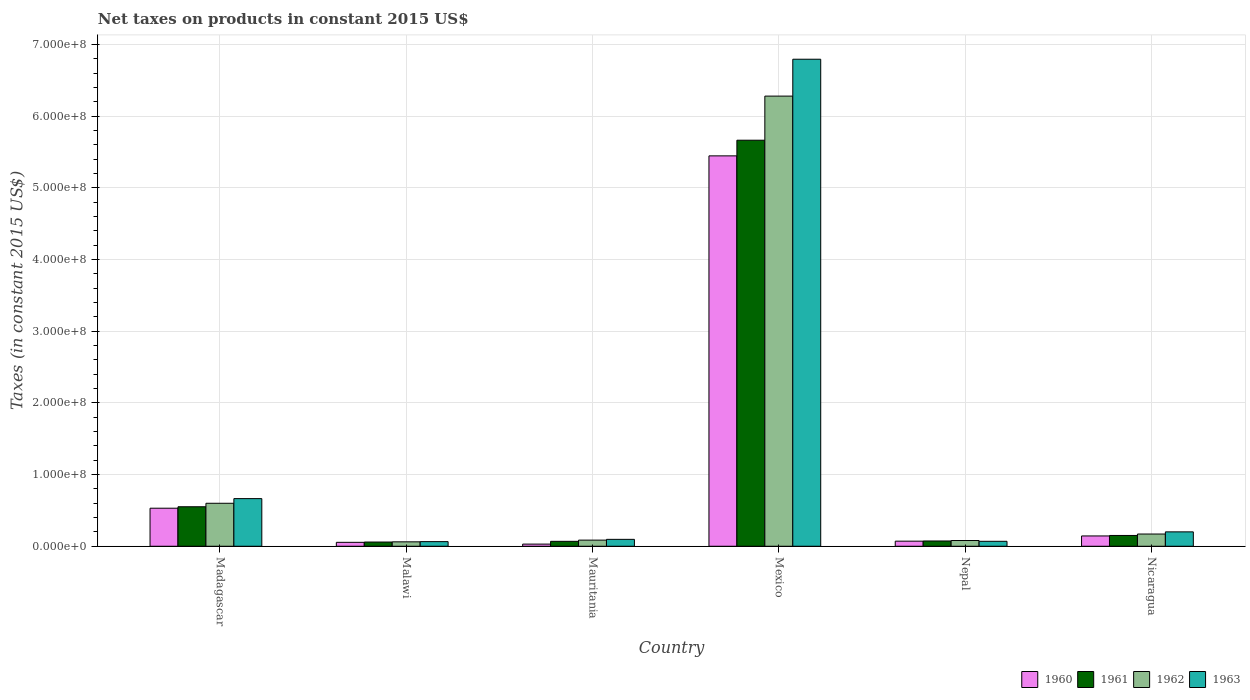How many groups of bars are there?
Your answer should be compact. 6. Are the number of bars on each tick of the X-axis equal?
Ensure brevity in your answer.  Yes. How many bars are there on the 4th tick from the left?
Provide a short and direct response. 4. In how many cases, is the number of bars for a given country not equal to the number of legend labels?
Your answer should be very brief. 0. What is the net taxes on products in 1962 in Mexico?
Offer a very short reply. 6.28e+08. Across all countries, what is the maximum net taxes on products in 1963?
Provide a succinct answer. 6.79e+08. Across all countries, what is the minimum net taxes on products in 1963?
Keep it short and to the point. 6.44e+06. In which country was the net taxes on products in 1962 maximum?
Offer a terse response. Mexico. In which country was the net taxes on products in 1960 minimum?
Keep it short and to the point. Mauritania. What is the total net taxes on products in 1961 in the graph?
Give a very brief answer. 6.57e+08. What is the difference between the net taxes on products in 1962 in Madagascar and that in Mexico?
Your answer should be very brief. -5.68e+08. What is the difference between the net taxes on products in 1962 in Nepal and the net taxes on products in 1963 in Mauritania?
Ensure brevity in your answer.  -1.62e+06. What is the average net taxes on products in 1960 per country?
Your answer should be compact. 1.05e+08. What is the difference between the net taxes on products of/in 1963 and net taxes on products of/in 1962 in Malawi?
Ensure brevity in your answer.  2.80e+05. In how many countries, is the net taxes on products in 1960 greater than 160000000 US$?
Provide a short and direct response. 1. What is the ratio of the net taxes on products in 1962 in Madagascar to that in Nicaragua?
Give a very brief answer. 3.51. Is the net taxes on products in 1962 in Nepal less than that in Nicaragua?
Ensure brevity in your answer.  Yes. What is the difference between the highest and the second highest net taxes on products in 1960?
Give a very brief answer. 3.87e+07. What is the difference between the highest and the lowest net taxes on products in 1960?
Your answer should be very brief. 5.42e+08. In how many countries, is the net taxes on products in 1961 greater than the average net taxes on products in 1961 taken over all countries?
Your answer should be compact. 1. Is the sum of the net taxes on products in 1961 in Malawi and Mexico greater than the maximum net taxes on products in 1962 across all countries?
Your answer should be very brief. No. Is it the case that in every country, the sum of the net taxes on products in 1961 and net taxes on products in 1960 is greater than the sum of net taxes on products in 1962 and net taxes on products in 1963?
Give a very brief answer. No. What does the 4th bar from the right in Mauritania represents?
Your answer should be very brief. 1960. How many bars are there?
Ensure brevity in your answer.  24. Are the values on the major ticks of Y-axis written in scientific E-notation?
Give a very brief answer. Yes. Does the graph contain any zero values?
Your response must be concise. No. Where does the legend appear in the graph?
Ensure brevity in your answer.  Bottom right. How many legend labels are there?
Keep it short and to the point. 4. What is the title of the graph?
Your response must be concise. Net taxes on products in constant 2015 US$. What is the label or title of the X-axis?
Your answer should be compact. Country. What is the label or title of the Y-axis?
Give a very brief answer. Taxes (in constant 2015 US$). What is the Taxes (in constant 2015 US$) of 1960 in Madagascar?
Your answer should be compact. 5.31e+07. What is the Taxes (in constant 2015 US$) in 1961 in Madagascar?
Your answer should be compact. 5.51e+07. What is the Taxes (in constant 2015 US$) in 1962 in Madagascar?
Your response must be concise. 6.00e+07. What is the Taxes (in constant 2015 US$) of 1963 in Madagascar?
Keep it short and to the point. 6.64e+07. What is the Taxes (in constant 2015 US$) in 1960 in Malawi?
Your answer should be very brief. 5.46e+06. What is the Taxes (in constant 2015 US$) of 1961 in Malawi?
Provide a succinct answer. 5.88e+06. What is the Taxes (in constant 2015 US$) in 1962 in Malawi?
Offer a very short reply. 6.16e+06. What is the Taxes (in constant 2015 US$) of 1963 in Malawi?
Your answer should be very brief. 6.44e+06. What is the Taxes (in constant 2015 US$) of 1960 in Mauritania?
Your answer should be very brief. 3.00e+06. What is the Taxes (in constant 2015 US$) in 1961 in Mauritania?
Offer a terse response. 6.85e+06. What is the Taxes (in constant 2015 US$) of 1962 in Mauritania?
Keep it short and to the point. 8.56e+06. What is the Taxes (in constant 2015 US$) of 1963 in Mauritania?
Keep it short and to the point. 9.63e+06. What is the Taxes (in constant 2015 US$) in 1960 in Mexico?
Provide a short and direct response. 5.45e+08. What is the Taxes (in constant 2015 US$) in 1961 in Mexico?
Provide a succinct answer. 5.66e+08. What is the Taxes (in constant 2015 US$) in 1962 in Mexico?
Give a very brief answer. 6.28e+08. What is the Taxes (in constant 2015 US$) of 1963 in Mexico?
Offer a terse response. 6.79e+08. What is the Taxes (in constant 2015 US$) in 1960 in Nepal?
Provide a short and direct response. 7.09e+06. What is the Taxes (in constant 2015 US$) in 1961 in Nepal?
Provide a short and direct response. 7.35e+06. What is the Taxes (in constant 2015 US$) of 1962 in Nepal?
Ensure brevity in your answer.  8.01e+06. What is the Taxes (in constant 2015 US$) of 1963 in Nepal?
Make the answer very short. 6.89e+06. What is the Taxes (in constant 2015 US$) of 1960 in Nicaragua?
Provide a short and direct response. 1.44e+07. What is the Taxes (in constant 2015 US$) of 1961 in Nicaragua?
Keep it short and to the point. 1.51e+07. What is the Taxes (in constant 2015 US$) in 1962 in Nicaragua?
Ensure brevity in your answer.  1.71e+07. What is the Taxes (in constant 2015 US$) of 1963 in Nicaragua?
Give a very brief answer. 2.01e+07. Across all countries, what is the maximum Taxes (in constant 2015 US$) in 1960?
Provide a succinct answer. 5.45e+08. Across all countries, what is the maximum Taxes (in constant 2015 US$) of 1961?
Your response must be concise. 5.66e+08. Across all countries, what is the maximum Taxes (in constant 2015 US$) of 1962?
Provide a short and direct response. 6.28e+08. Across all countries, what is the maximum Taxes (in constant 2015 US$) in 1963?
Your answer should be very brief. 6.79e+08. Across all countries, what is the minimum Taxes (in constant 2015 US$) of 1960?
Offer a terse response. 3.00e+06. Across all countries, what is the minimum Taxes (in constant 2015 US$) of 1961?
Offer a very short reply. 5.88e+06. Across all countries, what is the minimum Taxes (in constant 2015 US$) of 1962?
Your answer should be very brief. 6.16e+06. Across all countries, what is the minimum Taxes (in constant 2015 US$) in 1963?
Your answer should be very brief. 6.44e+06. What is the total Taxes (in constant 2015 US$) in 1960 in the graph?
Your response must be concise. 6.28e+08. What is the total Taxes (in constant 2015 US$) in 1961 in the graph?
Ensure brevity in your answer.  6.57e+08. What is the total Taxes (in constant 2015 US$) in 1962 in the graph?
Make the answer very short. 7.28e+08. What is the total Taxes (in constant 2015 US$) in 1963 in the graph?
Ensure brevity in your answer.  7.89e+08. What is the difference between the Taxes (in constant 2015 US$) of 1960 in Madagascar and that in Malawi?
Offer a terse response. 4.76e+07. What is the difference between the Taxes (in constant 2015 US$) in 1961 in Madagascar and that in Malawi?
Your answer should be very brief. 4.92e+07. What is the difference between the Taxes (in constant 2015 US$) of 1962 in Madagascar and that in Malawi?
Your answer should be compact. 5.38e+07. What is the difference between the Taxes (in constant 2015 US$) of 1963 in Madagascar and that in Malawi?
Provide a succinct answer. 6.00e+07. What is the difference between the Taxes (in constant 2015 US$) of 1960 in Madagascar and that in Mauritania?
Ensure brevity in your answer.  5.01e+07. What is the difference between the Taxes (in constant 2015 US$) of 1961 in Madagascar and that in Mauritania?
Your answer should be very brief. 4.82e+07. What is the difference between the Taxes (in constant 2015 US$) in 1962 in Madagascar and that in Mauritania?
Keep it short and to the point. 5.14e+07. What is the difference between the Taxes (in constant 2015 US$) in 1963 in Madagascar and that in Mauritania?
Keep it short and to the point. 5.68e+07. What is the difference between the Taxes (in constant 2015 US$) in 1960 in Madagascar and that in Mexico?
Keep it short and to the point. -4.91e+08. What is the difference between the Taxes (in constant 2015 US$) in 1961 in Madagascar and that in Mexico?
Provide a succinct answer. -5.11e+08. What is the difference between the Taxes (in constant 2015 US$) of 1962 in Madagascar and that in Mexico?
Offer a very short reply. -5.68e+08. What is the difference between the Taxes (in constant 2015 US$) of 1963 in Madagascar and that in Mexico?
Offer a terse response. -6.13e+08. What is the difference between the Taxes (in constant 2015 US$) of 1960 in Madagascar and that in Nepal?
Your answer should be compact. 4.60e+07. What is the difference between the Taxes (in constant 2015 US$) in 1961 in Madagascar and that in Nepal?
Make the answer very short. 4.77e+07. What is the difference between the Taxes (in constant 2015 US$) in 1962 in Madagascar and that in Nepal?
Your answer should be compact. 5.19e+07. What is the difference between the Taxes (in constant 2015 US$) of 1963 in Madagascar and that in Nepal?
Your answer should be very brief. 5.95e+07. What is the difference between the Taxes (in constant 2015 US$) in 1960 in Madagascar and that in Nicaragua?
Provide a succinct answer. 3.87e+07. What is the difference between the Taxes (in constant 2015 US$) in 1961 in Madagascar and that in Nicaragua?
Make the answer very short. 4.00e+07. What is the difference between the Taxes (in constant 2015 US$) in 1962 in Madagascar and that in Nicaragua?
Your answer should be very brief. 4.29e+07. What is the difference between the Taxes (in constant 2015 US$) in 1963 in Madagascar and that in Nicaragua?
Your answer should be compact. 4.64e+07. What is the difference between the Taxes (in constant 2015 US$) in 1960 in Malawi and that in Mauritania?
Give a very brief answer. 2.46e+06. What is the difference between the Taxes (in constant 2015 US$) in 1961 in Malawi and that in Mauritania?
Provide a succinct answer. -9.67e+05. What is the difference between the Taxes (in constant 2015 US$) of 1962 in Malawi and that in Mauritania?
Offer a terse response. -2.40e+06. What is the difference between the Taxes (in constant 2015 US$) of 1963 in Malawi and that in Mauritania?
Your answer should be compact. -3.19e+06. What is the difference between the Taxes (in constant 2015 US$) of 1960 in Malawi and that in Mexico?
Offer a terse response. -5.39e+08. What is the difference between the Taxes (in constant 2015 US$) of 1961 in Malawi and that in Mexico?
Provide a short and direct response. -5.61e+08. What is the difference between the Taxes (in constant 2015 US$) in 1962 in Malawi and that in Mexico?
Ensure brevity in your answer.  -6.22e+08. What is the difference between the Taxes (in constant 2015 US$) in 1963 in Malawi and that in Mexico?
Offer a very short reply. -6.73e+08. What is the difference between the Taxes (in constant 2015 US$) of 1960 in Malawi and that in Nepal?
Make the answer very short. -1.63e+06. What is the difference between the Taxes (in constant 2015 US$) of 1961 in Malawi and that in Nepal?
Make the answer very short. -1.47e+06. What is the difference between the Taxes (in constant 2015 US$) of 1962 in Malawi and that in Nepal?
Make the answer very short. -1.85e+06. What is the difference between the Taxes (in constant 2015 US$) in 1963 in Malawi and that in Nepal?
Keep it short and to the point. -4.50e+05. What is the difference between the Taxes (in constant 2015 US$) of 1960 in Malawi and that in Nicaragua?
Provide a succinct answer. -8.93e+06. What is the difference between the Taxes (in constant 2015 US$) in 1961 in Malawi and that in Nicaragua?
Offer a terse response. -9.18e+06. What is the difference between the Taxes (in constant 2015 US$) in 1962 in Malawi and that in Nicaragua?
Provide a succinct answer. -1.09e+07. What is the difference between the Taxes (in constant 2015 US$) of 1963 in Malawi and that in Nicaragua?
Make the answer very short. -1.36e+07. What is the difference between the Taxes (in constant 2015 US$) in 1960 in Mauritania and that in Mexico?
Give a very brief answer. -5.42e+08. What is the difference between the Taxes (in constant 2015 US$) of 1961 in Mauritania and that in Mexico?
Your answer should be very brief. -5.60e+08. What is the difference between the Taxes (in constant 2015 US$) in 1962 in Mauritania and that in Mexico?
Give a very brief answer. -6.19e+08. What is the difference between the Taxes (in constant 2015 US$) in 1963 in Mauritania and that in Mexico?
Offer a very short reply. -6.70e+08. What is the difference between the Taxes (in constant 2015 US$) of 1960 in Mauritania and that in Nepal?
Ensure brevity in your answer.  -4.09e+06. What is the difference between the Taxes (in constant 2015 US$) in 1961 in Mauritania and that in Nepal?
Your response must be concise. -5.03e+05. What is the difference between the Taxes (in constant 2015 US$) in 1962 in Mauritania and that in Nepal?
Offer a very short reply. 5.53e+05. What is the difference between the Taxes (in constant 2015 US$) of 1963 in Mauritania and that in Nepal?
Provide a succinct answer. 2.74e+06. What is the difference between the Taxes (in constant 2015 US$) in 1960 in Mauritania and that in Nicaragua?
Your answer should be compact. -1.14e+07. What is the difference between the Taxes (in constant 2015 US$) in 1961 in Mauritania and that in Nicaragua?
Make the answer very short. -8.21e+06. What is the difference between the Taxes (in constant 2015 US$) of 1962 in Mauritania and that in Nicaragua?
Provide a short and direct response. -8.50e+06. What is the difference between the Taxes (in constant 2015 US$) of 1963 in Mauritania and that in Nicaragua?
Ensure brevity in your answer.  -1.04e+07. What is the difference between the Taxes (in constant 2015 US$) in 1960 in Mexico and that in Nepal?
Your response must be concise. 5.37e+08. What is the difference between the Taxes (in constant 2015 US$) in 1961 in Mexico and that in Nepal?
Offer a very short reply. 5.59e+08. What is the difference between the Taxes (in constant 2015 US$) in 1962 in Mexico and that in Nepal?
Provide a succinct answer. 6.20e+08. What is the difference between the Taxes (in constant 2015 US$) in 1963 in Mexico and that in Nepal?
Make the answer very short. 6.72e+08. What is the difference between the Taxes (in constant 2015 US$) in 1960 in Mexico and that in Nicaragua?
Give a very brief answer. 5.30e+08. What is the difference between the Taxes (in constant 2015 US$) in 1961 in Mexico and that in Nicaragua?
Offer a very short reply. 5.51e+08. What is the difference between the Taxes (in constant 2015 US$) in 1962 in Mexico and that in Nicaragua?
Give a very brief answer. 6.11e+08. What is the difference between the Taxes (in constant 2015 US$) of 1963 in Mexico and that in Nicaragua?
Your answer should be very brief. 6.59e+08. What is the difference between the Taxes (in constant 2015 US$) of 1960 in Nepal and that in Nicaragua?
Your response must be concise. -7.30e+06. What is the difference between the Taxes (in constant 2015 US$) of 1961 in Nepal and that in Nicaragua?
Offer a very short reply. -7.71e+06. What is the difference between the Taxes (in constant 2015 US$) in 1962 in Nepal and that in Nicaragua?
Offer a very short reply. -9.06e+06. What is the difference between the Taxes (in constant 2015 US$) in 1963 in Nepal and that in Nicaragua?
Provide a short and direct response. -1.32e+07. What is the difference between the Taxes (in constant 2015 US$) in 1960 in Madagascar and the Taxes (in constant 2015 US$) in 1961 in Malawi?
Offer a terse response. 4.72e+07. What is the difference between the Taxes (in constant 2015 US$) of 1960 in Madagascar and the Taxes (in constant 2015 US$) of 1962 in Malawi?
Your answer should be compact. 4.69e+07. What is the difference between the Taxes (in constant 2015 US$) in 1960 in Madagascar and the Taxes (in constant 2015 US$) in 1963 in Malawi?
Provide a short and direct response. 4.66e+07. What is the difference between the Taxes (in constant 2015 US$) in 1961 in Madagascar and the Taxes (in constant 2015 US$) in 1962 in Malawi?
Give a very brief answer. 4.89e+07. What is the difference between the Taxes (in constant 2015 US$) of 1961 in Madagascar and the Taxes (in constant 2015 US$) of 1963 in Malawi?
Your response must be concise. 4.87e+07. What is the difference between the Taxes (in constant 2015 US$) of 1962 in Madagascar and the Taxes (in constant 2015 US$) of 1963 in Malawi?
Your response must be concise. 5.35e+07. What is the difference between the Taxes (in constant 2015 US$) of 1960 in Madagascar and the Taxes (in constant 2015 US$) of 1961 in Mauritania?
Your response must be concise. 4.62e+07. What is the difference between the Taxes (in constant 2015 US$) of 1960 in Madagascar and the Taxes (in constant 2015 US$) of 1962 in Mauritania?
Provide a short and direct response. 4.45e+07. What is the difference between the Taxes (in constant 2015 US$) of 1960 in Madagascar and the Taxes (in constant 2015 US$) of 1963 in Mauritania?
Your answer should be very brief. 4.34e+07. What is the difference between the Taxes (in constant 2015 US$) in 1961 in Madagascar and the Taxes (in constant 2015 US$) in 1962 in Mauritania?
Your answer should be very brief. 4.65e+07. What is the difference between the Taxes (in constant 2015 US$) of 1961 in Madagascar and the Taxes (in constant 2015 US$) of 1963 in Mauritania?
Provide a succinct answer. 4.55e+07. What is the difference between the Taxes (in constant 2015 US$) of 1962 in Madagascar and the Taxes (in constant 2015 US$) of 1963 in Mauritania?
Offer a very short reply. 5.03e+07. What is the difference between the Taxes (in constant 2015 US$) of 1960 in Madagascar and the Taxes (in constant 2015 US$) of 1961 in Mexico?
Your answer should be compact. -5.13e+08. What is the difference between the Taxes (in constant 2015 US$) in 1960 in Madagascar and the Taxes (in constant 2015 US$) in 1962 in Mexico?
Your answer should be compact. -5.75e+08. What is the difference between the Taxes (in constant 2015 US$) of 1960 in Madagascar and the Taxes (in constant 2015 US$) of 1963 in Mexico?
Give a very brief answer. -6.26e+08. What is the difference between the Taxes (in constant 2015 US$) of 1961 in Madagascar and the Taxes (in constant 2015 US$) of 1962 in Mexico?
Your answer should be compact. -5.73e+08. What is the difference between the Taxes (in constant 2015 US$) in 1961 in Madagascar and the Taxes (in constant 2015 US$) in 1963 in Mexico?
Offer a terse response. -6.24e+08. What is the difference between the Taxes (in constant 2015 US$) in 1962 in Madagascar and the Taxes (in constant 2015 US$) in 1963 in Mexico?
Your answer should be very brief. -6.19e+08. What is the difference between the Taxes (in constant 2015 US$) in 1960 in Madagascar and the Taxes (in constant 2015 US$) in 1961 in Nepal?
Your answer should be very brief. 4.57e+07. What is the difference between the Taxes (in constant 2015 US$) in 1960 in Madagascar and the Taxes (in constant 2015 US$) in 1962 in Nepal?
Give a very brief answer. 4.51e+07. What is the difference between the Taxes (in constant 2015 US$) of 1960 in Madagascar and the Taxes (in constant 2015 US$) of 1963 in Nepal?
Your answer should be compact. 4.62e+07. What is the difference between the Taxes (in constant 2015 US$) of 1961 in Madagascar and the Taxes (in constant 2015 US$) of 1962 in Nepal?
Ensure brevity in your answer.  4.71e+07. What is the difference between the Taxes (in constant 2015 US$) of 1961 in Madagascar and the Taxes (in constant 2015 US$) of 1963 in Nepal?
Your response must be concise. 4.82e+07. What is the difference between the Taxes (in constant 2015 US$) in 1962 in Madagascar and the Taxes (in constant 2015 US$) in 1963 in Nepal?
Ensure brevity in your answer.  5.31e+07. What is the difference between the Taxes (in constant 2015 US$) in 1960 in Madagascar and the Taxes (in constant 2015 US$) in 1961 in Nicaragua?
Offer a terse response. 3.80e+07. What is the difference between the Taxes (in constant 2015 US$) in 1960 in Madagascar and the Taxes (in constant 2015 US$) in 1962 in Nicaragua?
Your response must be concise. 3.60e+07. What is the difference between the Taxes (in constant 2015 US$) in 1960 in Madagascar and the Taxes (in constant 2015 US$) in 1963 in Nicaragua?
Make the answer very short. 3.30e+07. What is the difference between the Taxes (in constant 2015 US$) in 1961 in Madagascar and the Taxes (in constant 2015 US$) in 1962 in Nicaragua?
Your response must be concise. 3.80e+07. What is the difference between the Taxes (in constant 2015 US$) in 1961 in Madagascar and the Taxes (in constant 2015 US$) in 1963 in Nicaragua?
Offer a very short reply. 3.50e+07. What is the difference between the Taxes (in constant 2015 US$) of 1962 in Madagascar and the Taxes (in constant 2015 US$) of 1963 in Nicaragua?
Ensure brevity in your answer.  3.99e+07. What is the difference between the Taxes (in constant 2015 US$) in 1960 in Malawi and the Taxes (in constant 2015 US$) in 1961 in Mauritania?
Keep it short and to the point. -1.39e+06. What is the difference between the Taxes (in constant 2015 US$) in 1960 in Malawi and the Taxes (in constant 2015 US$) in 1962 in Mauritania?
Your response must be concise. -3.10e+06. What is the difference between the Taxes (in constant 2015 US$) of 1960 in Malawi and the Taxes (in constant 2015 US$) of 1963 in Mauritania?
Offer a very short reply. -4.17e+06. What is the difference between the Taxes (in constant 2015 US$) of 1961 in Malawi and the Taxes (in constant 2015 US$) of 1962 in Mauritania?
Offer a very short reply. -2.68e+06. What is the difference between the Taxes (in constant 2015 US$) of 1961 in Malawi and the Taxes (in constant 2015 US$) of 1963 in Mauritania?
Offer a terse response. -3.75e+06. What is the difference between the Taxes (in constant 2015 US$) of 1962 in Malawi and the Taxes (in constant 2015 US$) of 1963 in Mauritania?
Give a very brief answer. -3.47e+06. What is the difference between the Taxes (in constant 2015 US$) of 1960 in Malawi and the Taxes (in constant 2015 US$) of 1961 in Mexico?
Give a very brief answer. -5.61e+08. What is the difference between the Taxes (in constant 2015 US$) of 1960 in Malawi and the Taxes (in constant 2015 US$) of 1962 in Mexico?
Your answer should be very brief. -6.22e+08. What is the difference between the Taxes (in constant 2015 US$) of 1960 in Malawi and the Taxes (in constant 2015 US$) of 1963 in Mexico?
Your answer should be compact. -6.74e+08. What is the difference between the Taxes (in constant 2015 US$) of 1961 in Malawi and the Taxes (in constant 2015 US$) of 1962 in Mexico?
Make the answer very short. -6.22e+08. What is the difference between the Taxes (in constant 2015 US$) of 1961 in Malawi and the Taxes (in constant 2015 US$) of 1963 in Mexico?
Your response must be concise. -6.73e+08. What is the difference between the Taxes (in constant 2015 US$) of 1962 in Malawi and the Taxes (in constant 2015 US$) of 1963 in Mexico?
Provide a short and direct response. -6.73e+08. What is the difference between the Taxes (in constant 2015 US$) in 1960 in Malawi and the Taxes (in constant 2015 US$) in 1961 in Nepal?
Give a very brief answer. -1.89e+06. What is the difference between the Taxes (in constant 2015 US$) of 1960 in Malawi and the Taxes (in constant 2015 US$) of 1962 in Nepal?
Offer a terse response. -2.55e+06. What is the difference between the Taxes (in constant 2015 US$) of 1960 in Malawi and the Taxes (in constant 2015 US$) of 1963 in Nepal?
Provide a short and direct response. -1.43e+06. What is the difference between the Taxes (in constant 2015 US$) of 1961 in Malawi and the Taxes (in constant 2015 US$) of 1962 in Nepal?
Provide a short and direct response. -2.13e+06. What is the difference between the Taxes (in constant 2015 US$) in 1961 in Malawi and the Taxes (in constant 2015 US$) in 1963 in Nepal?
Provide a succinct answer. -1.01e+06. What is the difference between the Taxes (in constant 2015 US$) of 1962 in Malawi and the Taxes (in constant 2015 US$) of 1963 in Nepal?
Make the answer very short. -7.30e+05. What is the difference between the Taxes (in constant 2015 US$) of 1960 in Malawi and the Taxes (in constant 2015 US$) of 1961 in Nicaragua?
Your answer should be very brief. -9.60e+06. What is the difference between the Taxes (in constant 2015 US$) of 1960 in Malawi and the Taxes (in constant 2015 US$) of 1962 in Nicaragua?
Keep it short and to the point. -1.16e+07. What is the difference between the Taxes (in constant 2015 US$) in 1960 in Malawi and the Taxes (in constant 2015 US$) in 1963 in Nicaragua?
Your answer should be compact. -1.46e+07. What is the difference between the Taxes (in constant 2015 US$) in 1961 in Malawi and the Taxes (in constant 2015 US$) in 1962 in Nicaragua?
Give a very brief answer. -1.12e+07. What is the difference between the Taxes (in constant 2015 US$) of 1961 in Malawi and the Taxes (in constant 2015 US$) of 1963 in Nicaragua?
Provide a succinct answer. -1.42e+07. What is the difference between the Taxes (in constant 2015 US$) in 1962 in Malawi and the Taxes (in constant 2015 US$) in 1963 in Nicaragua?
Keep it short and to the point. -1.39e+07. What is the difference between the Taxes (in constant 2015 US$) in 1960 in Mauritania and the Taxes (in constant 2015 US$) in 1961 in Mexico?
Your answer should be very brief. -5.63e+08. What is the difference between the Taxes (in constant 2015 US$) of 1960 in Mauritania and the Taxes (in constant 2015 US$) of 1962 in Mexico?
Offer a very short reply. -6.25e+08. What is the difference between the Taxes (in constant 2015 US$) in 1960 in Mauritania and the Taxes (in constant 2015 US$) in 1963 in Mexico?
Your answer should be very brief. -6.76e+08. What is the difference between the Taxes (in constant 2015 US$) in 1961 in Mauritania and the Taxes (in constant 2015 US$) in 1962 in Mexico?
Provide a succinct answer. -6.21e+08. What is the difference between the Taxes (in constant 2015 US$) of 1961 in Mauritania and the Taxes (in constant 2015 US$) of 1963 in Mexico?
Your answer should be compact. -6.73e+08. What is the difference between the Taxes (in constant 2015 US$) of 1962 in Mauritania and the Taxes (in constant 2015 US$) of 1963 in Mexico?
Give a very brief answer. -6.71e+08. What is the difference between the Taxes (in constant 2015 US$) in 1960 in Mauritania and the Taxes (in constant 2015 US$) in 1961 in Nepal?
Ensure brevity in your answer.  -4.35e+06. What is the difference between the Taxes (in constant 2015 US$) in 1960 in Mauritania and the Taxes (in constant 2015 US$) in 1962 in Nepal?
Provide a short and direct response. -5.01e+06. What is the difference between the Taxes (in constant 2015 US$) of 1960 in Mauritania and the Taxes (in constant 2015 US$) of 1963 in Nepal?
Your response must be concise. -3.89e+06. What is the difference between the Taxes (in constant 2015 US$) in 1961 in Mauritania and the Taxes (in constant 2015 US$) in 1962 in Nepal?
Provide a succinct answer. -1.16e+06. What is the difference between the Taxes (in constant 2015 US$) in 1961 in Mauritania and the Taxes (in constant 2015 US$) in 1963 in Nepal?
Offer a terse response. -4.29e+04. What is the difference between the Taxes (in constant 2015 US$) of 1962 in Mauritania and the Taxes (in constant 2015 US$) of 1963 in Nepal?
Give a very brief answer. 1.67e+06. What is the difference between the Taxes (in constant 2015 US$) of 1960 in Mauritania and the Taxes (in constant 2015 US$) of 1961 in Nicaragua?
Offer a terse response. -1.21e+07. What is the difference between the Taxes (in constant 2015 US$) of 1960 in Mauritania and the Taxes (in constant 2015 US$) of 1962 in Nicaragua?
Ensure brevity in your answer.  -1.41e+07. What is the difference between the Taxes (in constant 2015 US$) in 1960 in Mauritania and the Taxes (in constant 2015 US$) in 1963 in Nicaragua?
Make the answer very short. -1.71e+07. What is the difference between the Taxes (in constant 2015 US$) of 1961 in Mauritania and the Taxes (in constant 2015 US$) of 1962 in Nicaragua?
Offer a terse response. -1.02e+07. What is the difference between the Taxes (in constant 2015 US$) in 1961 in Mauritania and the Taxes (in constant 2015 US$) in 1963 in Nicaragua?
Offer a terse response. -1.32e+07. What is the difference between the Taxes (in constant 2015 US$) of 1962 in Mauritania and the Taxes (in constant 2015 US$) of 1963 in Nicaragua?
Keep it short and to the point. -1.15e+07. What is the difference between the Taxes (in constant 2015 US$) in 1960 in Mexico and the Taxes (in constant 2015 US$) in 1961 in Nepal?
Your answer should be compact. 5.37e+08. What is the difference between the Taxes (in constant 2015 US$) of 1960 in Mexico and the Taxes (in constant 2015 US$) of 1962 in Nepal?
Provide a succinct answer. 5.37e+08. What is the difference between the Taxes (in constant 2015 US$) in 1960 in Mexico and the Taxes (in constant 2015 US$) in 1963 in Nepal?
Provide a succinct answer. 5.38e+08. What is the difference between the Taxes (in constant 2015 US$) in 1961 in Mexico and the Taxes (in constant 2015 US$) in 1962 in Nepal?
Offer a very short reply. 5.58e+08. What is the difference between the Taxes (in constant 2015 US$) in 1961 in Mexico and the Taxes (in constant 2015 US$) in 1963 in Nepal?
Offer a terse response. 5.60e+08. What is the difference between the Taxes (in constant 2015 US$) in 1962 in Mexico and the Taxes (in constant 2015 US$) in 1963 in Nepal?
Keep it short and to the point. 6.21e+08. What is the difference between the Taxes (in constant 2015 US$) of 1960 in Mexico and the Taxes (in constant 2015 US$) of 1961 in Nicaragua?
Give a very brief answer. 5.30e+08. What is the difference between the Taxes (in constant 2015 US$) in 1960 in Mexico and the Taxes (in constant 2015 US$) in 1962 in Nicaragua?
Your answer should be very brief. 5.28e+08. What is the difference between the Taxes (in constant 2015 US$) of 1960 in Mexico and the Taxes (in constant 2015 US$) of 1963 in Nicaragua?
Provide a succinct answer. 5.24e+08. What is the difference between the Taxes (in constant 2015 US$) of 1961 in Mexico and the Taxes (in constant 2015 US$) of 1962 in Nicaragua?
Your answer should be compact. 5.49e+08. What is the difference between the Taxes (in constant 2015 US$) in 1961 in Mexico and the Taxes (in constant 2015 US$) in 1963 in Nicaragua?
Provide a succinct answer. 5.46e+08. What is the difference between the Taxes (in constant 2015 US$) in 1962 in Mexico and the Taxes (in constant 2015 US$) in 1963 in Nicaragua?
Make the answer very short. 6.08e+08. What is the difference between the Taxes (in constant 2015 US$) of 1960 in Nepal and the Taxes (in constant 2015 US$) of 1961 in Nicaragua?
Your answer should be compact. -7.97e+06. What is the difference between the Taxes (in constant 2015 US$) of 1960 in Nepal and the Taxes (in constant 2015 US$) of 1962 in Nicaragua?
Your response must be concise. -9.98e+06. What is the difference between the Taxes (in constant 2015 US$) of 1960 in Nepal and the Taxes (in constant 2015 US$) of 1963 in Nicaragua?
Your answer should be compact. -1.30e+07. What is the difference between the Taxes (in constant 2015 US$) in 1961 in Nepal and the Taxes (in constant 2015 US$) in 1962 in Nicaragua?
Provide a short and direct response. -9.71e+06. What is the difference between the Taxes (in constant 2015 US$) in 1961 in Nepal and the Taxes (in constant 2015 US$) in 1963 in Nicaragua?
Ensure brevity in your answer.  -1.27e+07. What is the difference between the Taxes (in constant 2015 US$) of 1962 in Nepal and the Taxes (in constant 2015 US$) of 1963 in Nicaragua?
Provide a succinct answer. -1.21e+07. What is the average Taxes (in constant 2015 US$) in 1960 per country?
Offer a terse response. 1.05e+08. What is the average Taxes (in constant 2015 US$) in 1961 per country?
Offer a very short reply. 1.09e+08. What is the average Taxes (in constant 2015 US$) in 1962 per country?
Give a very brief answer. 1.21e+08. What is the average Taxes (in constant 2015 US$) in 1963 per country?
Your response must be concise. 1.31e+08. What is the difference between the Taxes (in constant 2015 US$) of 1960 and Taxes (in constant 2015 US$) of 1961 in Madagascar?
Ensure brevity in your answer.  -2.03e+06. What is the difference between the Taxes (in constant 2015 US$) in 1960 and Taxes (in constant 2015 US$) in 1962 in Madagascar?
Provide a short and direct response. -6.89e+06. What is the difference between the Taxes (in constant 2015 US$) of 1960 and Taxes (in constant 2015 US$) of 1963 in Madagascar?
Offer a very short reply. -1.34e+07. What is the difference between the Taxes (in constant 2015 US$) of 1961 and Taxes (in constant 2015 US$) of 1962 in Madagascar?
Your answer should be very brief. -4.86e+06. What is the difference between the Taxes (in constant 2015 US$) of 1961 and Taxes (in constant 2015 US$) of 1963 in Madagascar?
Your response must be concise. -1.13e+07. What is the difference between the Taxes (in constant 2015 US$) of 1962 and Taxes (in constant 2015 US$) of 1963 in Madagascar?
Offer a very short reply. -6.48e+06. What is the difference between the Taxes (in constant 2015 US$) in 1960 and Taxes (in constant 2015 US$) in 1961 in Malawi?
Your answer should be compact. -4.20e+05. What is the difference between the Taxes (in constant 2015 US$) of 1960 and Taxes (in constant 2015 US$) of 1962 in Malawi?
Your response must be concise. -7.00e+05. What is the difference between the Taxes (in constant 2015 US$) of 1960 and Taxes (in constant 2015 US$) of 1963 in Malawi?
Your answer should be very brief. -9.80e+05. What is the difference between the Taxes (in constant 2015 US$) of 1961 and Taxes (in constant 2015 US$) of 1962 in Malawi?
Provide a succinct answer. -2.80e+05. What is the difference between the Taxes (in constant 2015 US$) of 1961 and Taxes (in constant 2015 US$) of 1963 in Malawi?
Provide a succinct answer. -5.60e+05. What is the difference between the Taxes (in constant 2015 US$) of 1962 and Taxes (in constant 2015 US$) of 1963 in Malawi?
Offer a terse response. -2.80e+05. What is the difference between the Taxes (in constant 2015 US$) of 1960 and Taxes (in constant 2015 US$) of 1961 in Mauritania?
Your answer should be very brief. -3.85e+06. What is the difference between the Taxes (in constant 2015 US$) of 1960 and Taxes (in constant 2015 US$) of 1962 in Mauritania?
Provide a short and direct response. -5.56e+06. What is the difference between the Taxes (in constant 2015 US$) of 1960 and Taxes (in constant 2015 US$) of 1963 in Mauritania?
Your response must be concise. -6.63e+06. What is the difference between the Taxes (in constant 2015 US$) in 1961 and Taxes (in constant 2015 US$) in 1962 in Mauritania?
Give a very brief answer. -1.71e+06. What is the difference between the Taxes (in constant 2015 US$) of 1961 and Taxes (in constant 2015 US$) of 1963 in Mauritania?
Your answer should be compact. -2.78e+06. What is the difference between the Taxes (in constant 2015 US$) in 1962 and Taxes (in constant 2015 US$) in 1963 in Mauritania?
Ensure brevity in your answer.  -1.07e+06. What is the difference between the Taxes (in constant 2015 US$) of 1960 and Taxes (in constant 2015 US$) of 1961 in Mexico?
Provide a short and direct response. -2.18e+07. What is the difference between the Taxes (in constant 2015 US$) of 1960 and Taxes (in constant 2015 US$) of 1962 in Mexico?
Provide a short and direct response. -8.34e+07. What is the difference between the Taxes (in constant 2015 US$) in 1960 and Taxes (in constant 2015 US$) in 1963 in Mexico?
Ensure brevity in your answer.  -1.35e+08. What is the difference between the Taxes (in constant 2015 US$) in 1961 and Taxes (in constant 2015 US$) in 1962 in Mexico?
Offer a very short reply. -6.15e+07. What is the difference between the Taxes (in constant 2015 US$) in 1961 and Taxes (in constant 2015 US$) in 1963 in Mexico?
Your answer should be very brief. -1.13e+08. What is the difference between the Taxes (in constant 2015 US$) of 1962 and Taxes (in constant 2015 US$) of 1963 in Mexico?
Your response must be concise. -5.14e+07. What is the difference between the Taxes (in constant 2015 US$) of 1960 and Taxes (in constant 2015 US$) of 1961 in Nepal?
Offer a terse response. -2.63e+05. What is the difference between the Taxes (in constant 2015 US$) of 1960 and Taxes (in constant 2015 US$) of 1962 in Nepal?
Your answer should be very brief. -9.19e+05. What is the difference between the Taxes (in constant 2015 US$) of 1960 and Taxes (in constant 2015 US$) of 1963 in Nepal?
Give a very brief answer. 1.97e+05. What is the difference between the Taxes (in constant 2015 US$) of 1961 and Taxes (in constant 2015 US$) of 1962 in Nepal?
Keep it short and to the point. -6.56e+05. What is the difference between the Taxes (in constant 2015 US$) of 1961 and Taxes (in constant 2015 US$) of 1963 in Nepal?
Ensure brevity in your answer.  4.60e+05. What is the difference between the Taxes (in constant 2015 US$) of 1962 and Taxes (in constant 2015 US$) of 1963 in Nepal?
Offer a very short reply. 1.12e+06. What is the difference between the Taxes (in constant 2015 US$) of 1960 and Taxes (in constant 2015 US$) of 1961 in Nicaragua?
Keep it short and to the point. -6.69e+05. What is the difference between the Taxes (in constant 2015 US$) in 1960 and Taxes (in constant 2015 US$) in 1962 in Nicaragua?
Provide a short and direct response. -2.68e+06. What is the difference between the Taxes (in constant 2015 US$) of 1960 and Taxes (in constant 2015 US$) of 1963 in Nicaragua?
Your response must be concise. -5.69e+06. What is the difference between the Taxes (in constant 2015 US$) of 1961 and Taxes (in constant 2015 US$) of 1962 in Nicaragua?
Ensure brevity in your answer.  -2.01e+06. What is the difference between the Taxes (in constant 2015 US$) of 1961 and Taxes (in constant 2015 US$) of 1963 in Nicaragua?
Your response must be concise. -5.02e+06. What is the difference between the Taxes (in constant 2015 US$) of 1962 and Taxes (in constant 2015 US$) of 1963 in Nicaragua?
Your answer should be very brief. -3.01e+06. What is the ratio of the Taxes (in constant 2015 US$) of 1960 in Madagascar to that in Malawi?
Offer a terse response. 9.72. What is the ratio of the Taxes (in constant 2015 US$) in 1961 in Madagascar to that in Malawi?
Keep it short and to the point. 9.37. What is the ratio of the Taxes (in constant 2015 US$) of 1962 in Madagascar to that in Malawi?
Your answer should be compact. 9.73. What is the ratio of the Taxes (in constant 2015 US$) of 1963 in Madagascar to that in Malawi?
Offer a terse response. 10.32. What is the ratio of the Taxes (in constant 2015 US$) of 1960 in Madagascar to that in Mauritania?
Make the answer very short. 17.72. What is the ratio of the Taxes (in constant 2015 US$) in 1961 in Madagascar to that in Mauritania?
Keep it short and to the point. 8.05. What is the ratio of the Taxes (in constant 2015 US$) of 1962 in Madagascar to that in Mauritania?
Ensure brevity in your answer.  7. What is the ratio of the Taxes (in constant 2015 US$) in 1963 in Madagascar to that in Mauritania?
Ensure brevity in your answer.  6.9. What is the ratio of the Taxes (in constant 2015 US$) in 1960 in Madagascar to that in Mexico?
Provide a succinct answer. 0.1. What is the ratio of the Taxes (in constant 2015 US$) in 1961 in Madagascar to that in Mexico?
Provide a short and direct response. 0.1. What is the ratio of the Taxes (in constant 2015 US$) in 1962 in Madagascar to that in Mexico?
Ensure brevity in your answer.  0.1. What is the ratio of the Taxes (in constant 2015 US$) in 1963 in Madagascar to that in Mexico?
Make the answer very short. 0.1. What is the ratio of the Taxes (in constant 2015 US$) of 1960 in Madagascar to that in Nepal?
Offer a very short reply. 7.49. What is the ratio of the Taxes (in constant 2015 US$) in 1961 in Madagascar to that in Nepal?
Keep it short and to the point. 7.5. What is the ratio of the Taxes (in constant 2015 US$) in 1962 in Madagascar to that in Nepal?
Offer a terse response. 7.49. What is the ratio of the Taxes (in constant 2015 US$) of 1963 in Madagascar to that in Nepal?
Provide a succinct answer. 9.64. What is the ratio of the Taxes (in constant 2015 US$) in 1960 in Madagascar to that in Nicaragua?
Provide a short and direct response. 3.69. What is the ratio of the Taxes (in constant 2015 US$) in 1961 in Madagascar to that in Nicaragua?
Offer a very short reply. 3.66. What is the ratio of the Taxes (in constant 2015 US$) of 1962 in Madagascar to that in Nicaragua?
Your answer should be very brief. 3.51. What is the ratio of the Taxes (in constant 2015 US$) of 1963 in Madagascar to that in Nicaragua?
Provide a succinct answer. 3.31. What is the ratio of the Taxes (in constant 2015 US$) in 1960 in Malawi to that in Mauritania?
Your response must be concise. 1.82. What is the ratio of the Taxes (in constant 2015 US$) in 1961 in Malawi to that in Mauritania?
Provide a short and direct response. 0.86. What is the ratio of the Taxes (in constant 2015 US$) of 1962 in Malawi to that in Mauritania?
Give a very brief answer. 0.72. What is the ratio of the Taxes (in constant 2015 US$) of 1963 in Malawi to that in Mauritania?
Offer a terse response. 0.67. What is the ratio of the Taxes (in constant 2015 US$) in 1961 in Malawi to that in Mexico?
Offer a terse response. 0.01. What is the ratio of the Taxes (in constant 2015 US$) in 1962 in Malawi to that in Mexico?
Offer a terse response. 0.01. What is the ratio of the Taxes (in constant 2015 US$) in 1963 in Malawi to that in Mexico?
Your response must be concise. 0.01. What is the ratio of the Taxes (in constant 2015 US$) in 1960 in Malawi to that in Nepal?
Provide a short and direct response. 0.77. What is the ratio of the Taxes (in constant 2015 US$) in 1961 in Malawi to that in Nepal?
Keep it short and to the point. 0.8. What is the ratio of the Taxes (in constant 2015 US$) in 1962 in Malawi to that in Nepal?
Your answer should be compact. 0.77. What is the ratio of the Taxes (in constant 2015 US$) of 1963 in Malawi to that in Nepal?
Give a very brief answer. 0.93. What is the ratio of the Taxes (in constant 2015 US$) of 1960 in Malawi to that in Nicaragua?
Provide a short and direct response. 0.38. What is the ratio of the Taxes (in constant 2015 US$) in 1961 in Malawi to that in Nicaragua?
Provide a short and direct response. 0.39. What is the ratio of the Taxes (in constant 2015 US$) of 1962 in Malawi to that in Nicaragua?
Your answer should be compact. 0.36. What is the ratio of the Taxes (in constant 2015 US$) of 1963 in Malawi to that in Nicaragua?
Your answer should be very brief. 0.32. What is the ratio of the Taxes (in constant 2015 US$) in 1960 in Mauritania to that in Mexico?
Provide a short and direct response. 0.01. What is the ratio of the Taxes (in constant 2015 US$) of 1961 in Mauritania to that in Mexico?
Make the answer very short. 0.01. What is the ratio of the Taxes (in constant 2015 US$) of 1962 in Mauritania to that in Mexico?
Keep it short and to the point. 0.01. What is the ratio of the Taxes (in constant 2015 US$) in 1963 in Mauritania to that in Mexico?
Give a very brief answer. 0.01. What is the ratio of the Taxes (in constant 2015 US$) of 1960 in Mauritania to that in Nepal?
Keep it short and to the point. 0.42. What is the ratio of the Taxes (in constant 2015 US$) in 1961 in Mauritania to that in Nepal?
Your answer should be very brief. 0.93. What is the ratio of the Taxes (in constant 2015 US$) in 1962 in Mauritania to that in Nepal?
Offer a terse response. 1.07. What is the ratio of the Taxes (in constant 2015 US$) in 1963 in Mauritania to that in Nepal?
Your response must be concise. 1.4. What is the ratio of the Taxes (in constant 2015 US$) of 1960 in Mauritania to that in Nicaragua?
Provide a short and direct response. 0.21. What is the ratio of the Taxes (in constant 2015 US$) in 1961 in Mauritania to that in Nicaragua?
Your answer should be very brief. 0.45. What is the ratio of the Taxes (in constant 2015 US$) in 1962 in Mauritania to that in Nicaragua?
Provide a succinct answer. 0.5. What is the ratio of the Taxes (in constant 2015 US$) in 1963 in Mauritania to that in Nicaragua?
Your answer should be compact. 0.48. What is the ratio of the Taxes (in constant 2015 US$) in 1960 in Mexico to that in Nepal?
Offer a very short reply. 76.83. What is the ratio of the Taxes (in constant 2015 US$) of 1961 in Mexico to that in Nepal?
Your response must be concise. 77.06. What is the ratio of the Taxes (in constant 2015 US$) in 1962 in Mexico to that in Nepal?
Provide a succinct answer. 78.43. What is the ratio of the Taxes (in constant 2015 US$) of 1963 in Mexico to that in Nepal?
Provide a short and direct response. 98.6. What is the ratio of the Taxes (in constant 2015 US$) in 1960 in Mexico to that in Nicaragua?
Offer a very short reply. 37.85. What is the ratio of the Taxes (in constant 2015 US$) in 1961 in Mexico to that in Nicaragua?
Provide a short and direct response. 37.62. What is the ratio of the Taxes (in constant 2015 US$) in 1962 in Mexico to that in Nicaragua?
Provide a short and direct response. 36.8. What is the ratio of the Taxes (in constant 2015 US$) of 1963 in Mexico to that in Nicaragua?
Give a very brief answer. 33.84. What is the ratio of the Taxes (in constant 2015 US$) in 1960 in Nepal to that in Nicaragua?
Ensure brevity in your answer.  0.49. What is the ratio of the Taxes (in constant 2015 US$) in 1961 in Nepal to that in Nicaragua?
Offer a terse response. 0.49. What is the ratio of the Taxes (in constant 2015 US$) in 1962 in Nepal to that in Nicaragua?
Your answer should be compact. 0.47. What is the ratio of the Taxes (in constant 2015 US$) of 1963 in Nepal to that in Nicaragua?
Ensure brevity in your answer.  0.34. What is the difference between the highest and the second highest Taxes (in constant 2015 US$) in 1960?
Your answer should be very brief. 4.91e+08. What is the difference between the highest and the second highest Taxes (in constant 2015 US$) in 1961?
Make the answer very short. 5.11e+08. What is the difference between the highest and the second highest Taxes (in constant 2015 US$) of 1962?
Provide a short and direct response. 5.68e+08. What is the difference between the highest and the second highest Taxes (in constant 2015 US$) in 1963?
Give a very brief answer. 6.13e+08. What is the difference between the highest and the lowest Taxes (in constant 2015 US$) of 1960?
Make the answer very short. 5.42e+08. What is the difference between the highest and the lowest Taxes (in constant 2015 US$) in 1961?
Your response must be concise. 5.61e+08. What is the difference between the highest and the lowest Taxes (in constant 2015 US$) in 1962?
Your answer should be very brief. 6.22e+08. What is the difference between the highest and the lowest Taxes (in constant 2015 US$) of 1963?
Offer a terse response. 6.73e+08. 